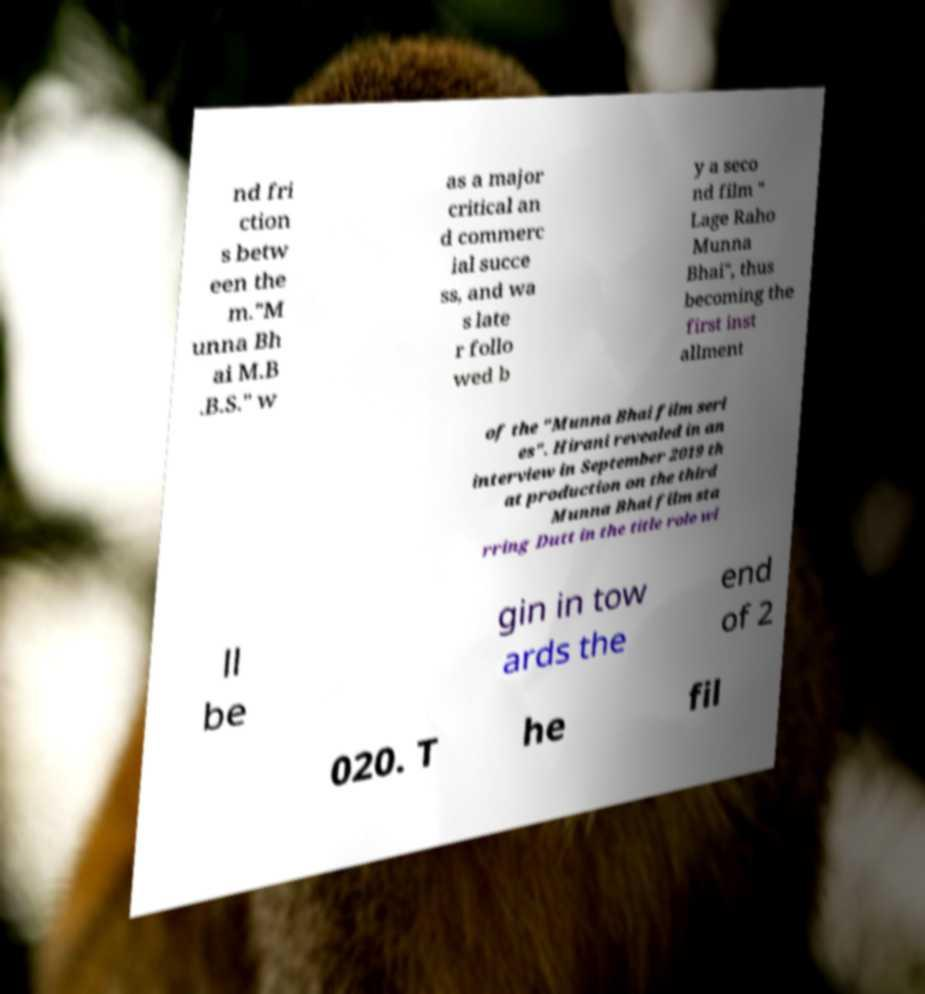Please identify and transcribe the text found in this image. nd fri ction s betw een the m."M unna Bh ai M.B .B.S." w as a major critical an d commerc ial succe ss, and wa s late r follo wed b y a seco nd film " Lage Raho Munna Bhai", thus becoming the first inst allment of the "Munna Bhai film seri es". Hirani revealed in an interview in September 2019 th at production on the third Munna Bhai film sta rring Dutt in the title role wi ll be gin in tow ards the end of 2 020. T he fil 